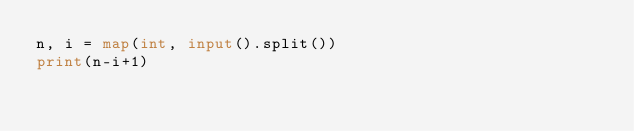Convert code to text. <code><loc_0><loc_0><loc_500><loc_500><_Python_>n, i = map(int, input().split())
print(n-i+1)</code> 